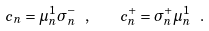Convert formula to latex. <formula><loc_0><loc_0><loc_500><loc_500>c _ { n } = \mu ^ { 1 } _ { n } \sigma ^ { - } _ { n } \ , \quad c ^ { + } _ { n } = \sigma ^ { + } _ { n } \mu ^ { 1 } _ { n } \ .</formula> 